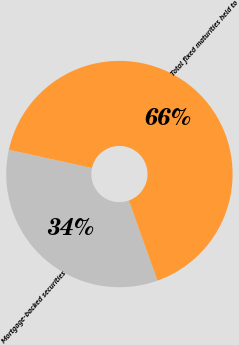Convert chart. <chart><loc_0><loc_0><loc_500><loc_500><pie_chart><fcel>Mortgage-backed securities<fcel>Total fixed maturities held to<nl><fcel>33.9%<fcel>66.1%<nl></chart> 